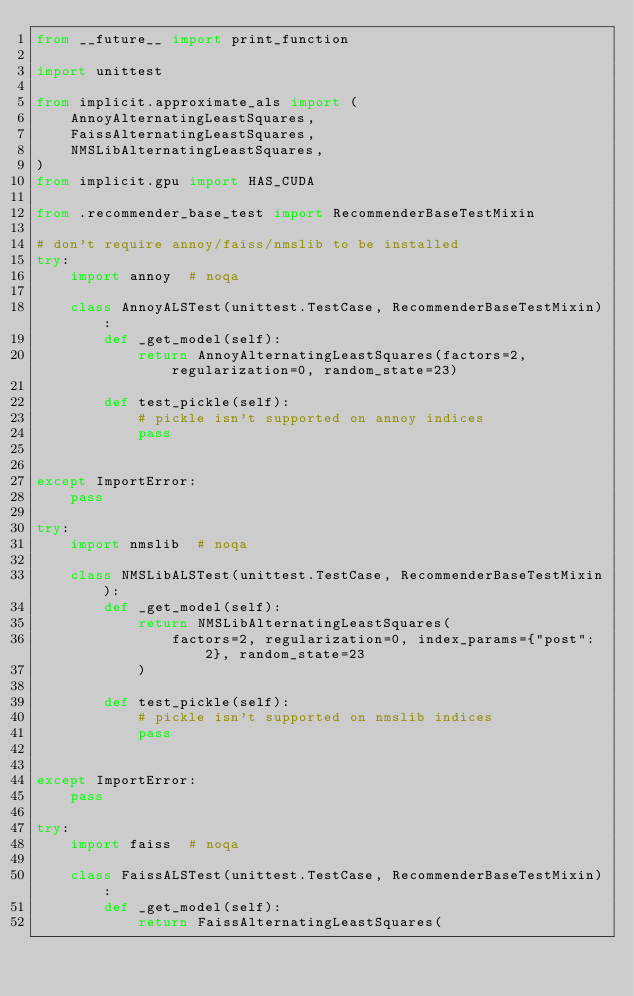Convert code to text. <code><loc_0><loc_0><loc_500><loc_500><_Python_>from __future__ import print_function

import unittest

from implicit.approximate_als import (
    AnnoyAlternatingLeastSquares,
    FaissAlternatingLeastSquares,
    NMSLibAlternatingLeastSquares,
)
from implicit.gpu import HAS_CUDA

from .recommender_base_test import RecommenderBaseTestMixin

# don't require annoy/faiss/nmslib to be installed
try:
    import annoy  # noqa

    class AnnoyALSTest(unittest.TestCase, RecommenderBaseTestMixin):
        def _get_model(self):
            return AnnoyAlternatingLeastSquares(factors=2, regularization=0, random_state=23)

        def test_pickle(self):
            # pickle isn't supported on annoy indices
            pass


except ImportError:
    pass

try:
    import nmslib  # noqa

    class NMSLibALSTest(unittest.TestCase, RecommenderBaseTestMixin):
        def _get_model(self):
            return NMSLibAlternatingLeastSquares(
                factors=2, regularization=0, index_params={"post": 2}, random_state=23
            )

        def test_pickle(self):
            # pickle isn't supported on nmslib indices
            pass


except ImportError:
    pass

try:
    import faiss  # noqa

    class FaissALSTest(unittest.TestCase, RecommenderBaseTestMixin):
        def _get_model(self):
            return FaissAlternatingLeastSquares(</code> 